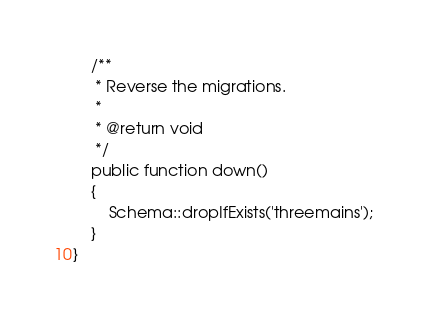<code> <loc_0><loc_0><loc_500><loc_500><_PHP_>
    /**
     * Reverse the migrations.
     *
     * @return void
     */
    public function down()
    {
        Schema::dropIfExists('threemains');
    }
}
</code> 